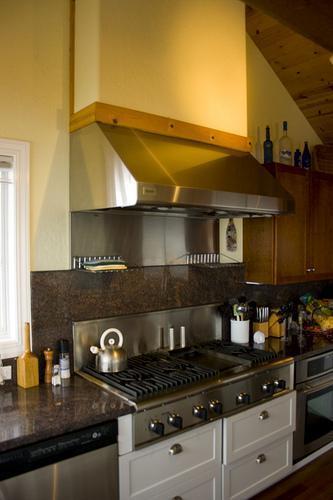How many stoves?
Give a very brief answer. 1. 